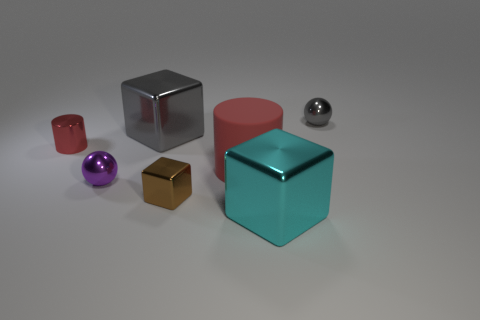Subtract all small shiny blocks. How many blocks are left? 2 Add 2 large spheres. How many objects exist? 9 Subtract all purple balls. How many balls are left? 1 Subtract all balls. How many objects are left? 5 Subtract all brown blocks. Subtract all green cylinders. How many blocks are left? 2 Subtract all tiny cylinders. Subtract all gray metal balls. How many objects are left? 5 Add 6 gray metal blocks. How many gray metal blocks are left? 7 Add 2 metallic things. How many metallic things exist? 8 Subtract 1 cyan cubes. How many objects are left? 6 